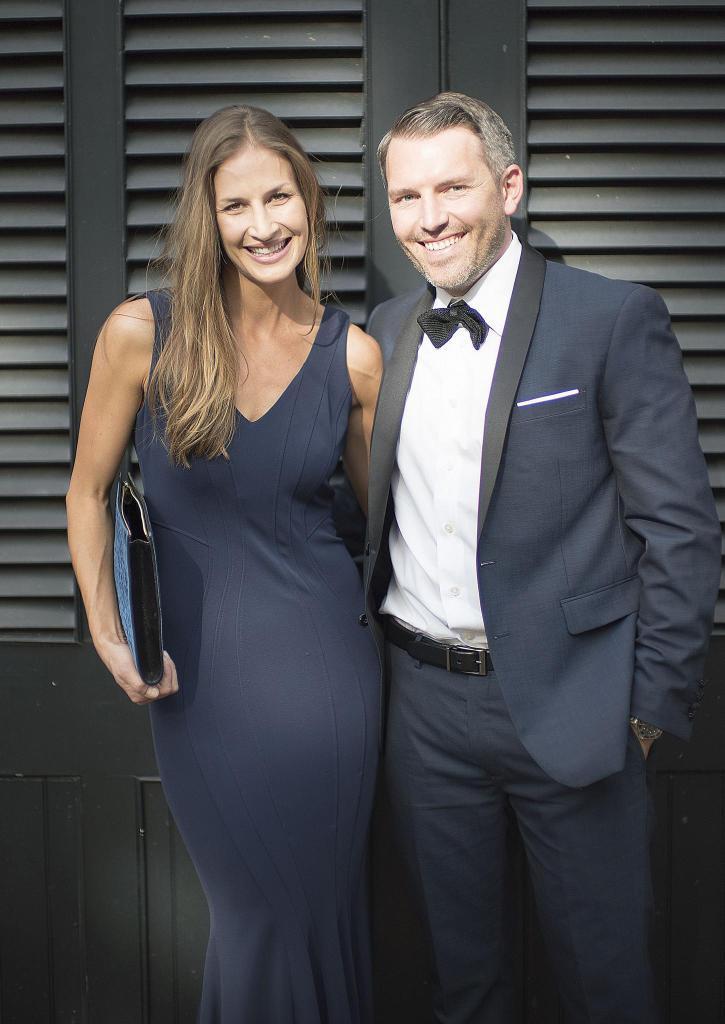Can you describe this image briefly? Here we can see a woman and man and the woman is holding a file in her hand. In the background there is a door. 